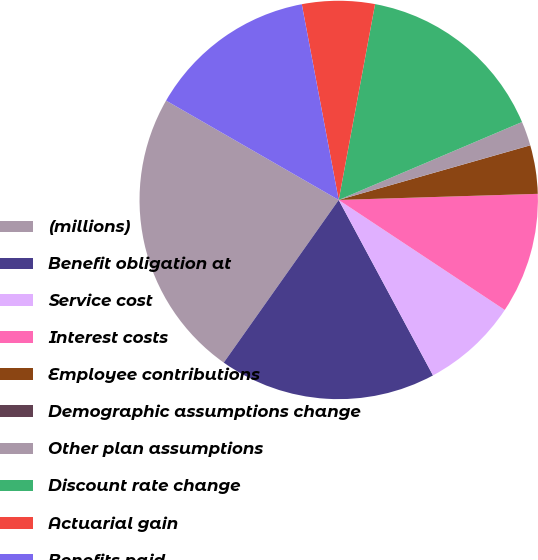<chart> <loc_0><loc_0><loc_500><loc_500><pie_chart><fcel>(millions)<fcel>Benefit obligation at<fcel>Service cost<fcel>Interest costs<fcel>Employee contributions<fcel>Demographic assumptions change<fcel>Other plan assumptions<fcel>Discount rate change<fcel>Actuarial gain<fcel>Benefits paid<nl><fcel>23.52%<fcel>17.64%<fcel>7.84%<fcel>9.8%<fcel>3.93%<fcel>0.01%<fcel>1.97%<fcel>15.68%<fcel>5.89%<fcel>13.72%<nl></chart> 